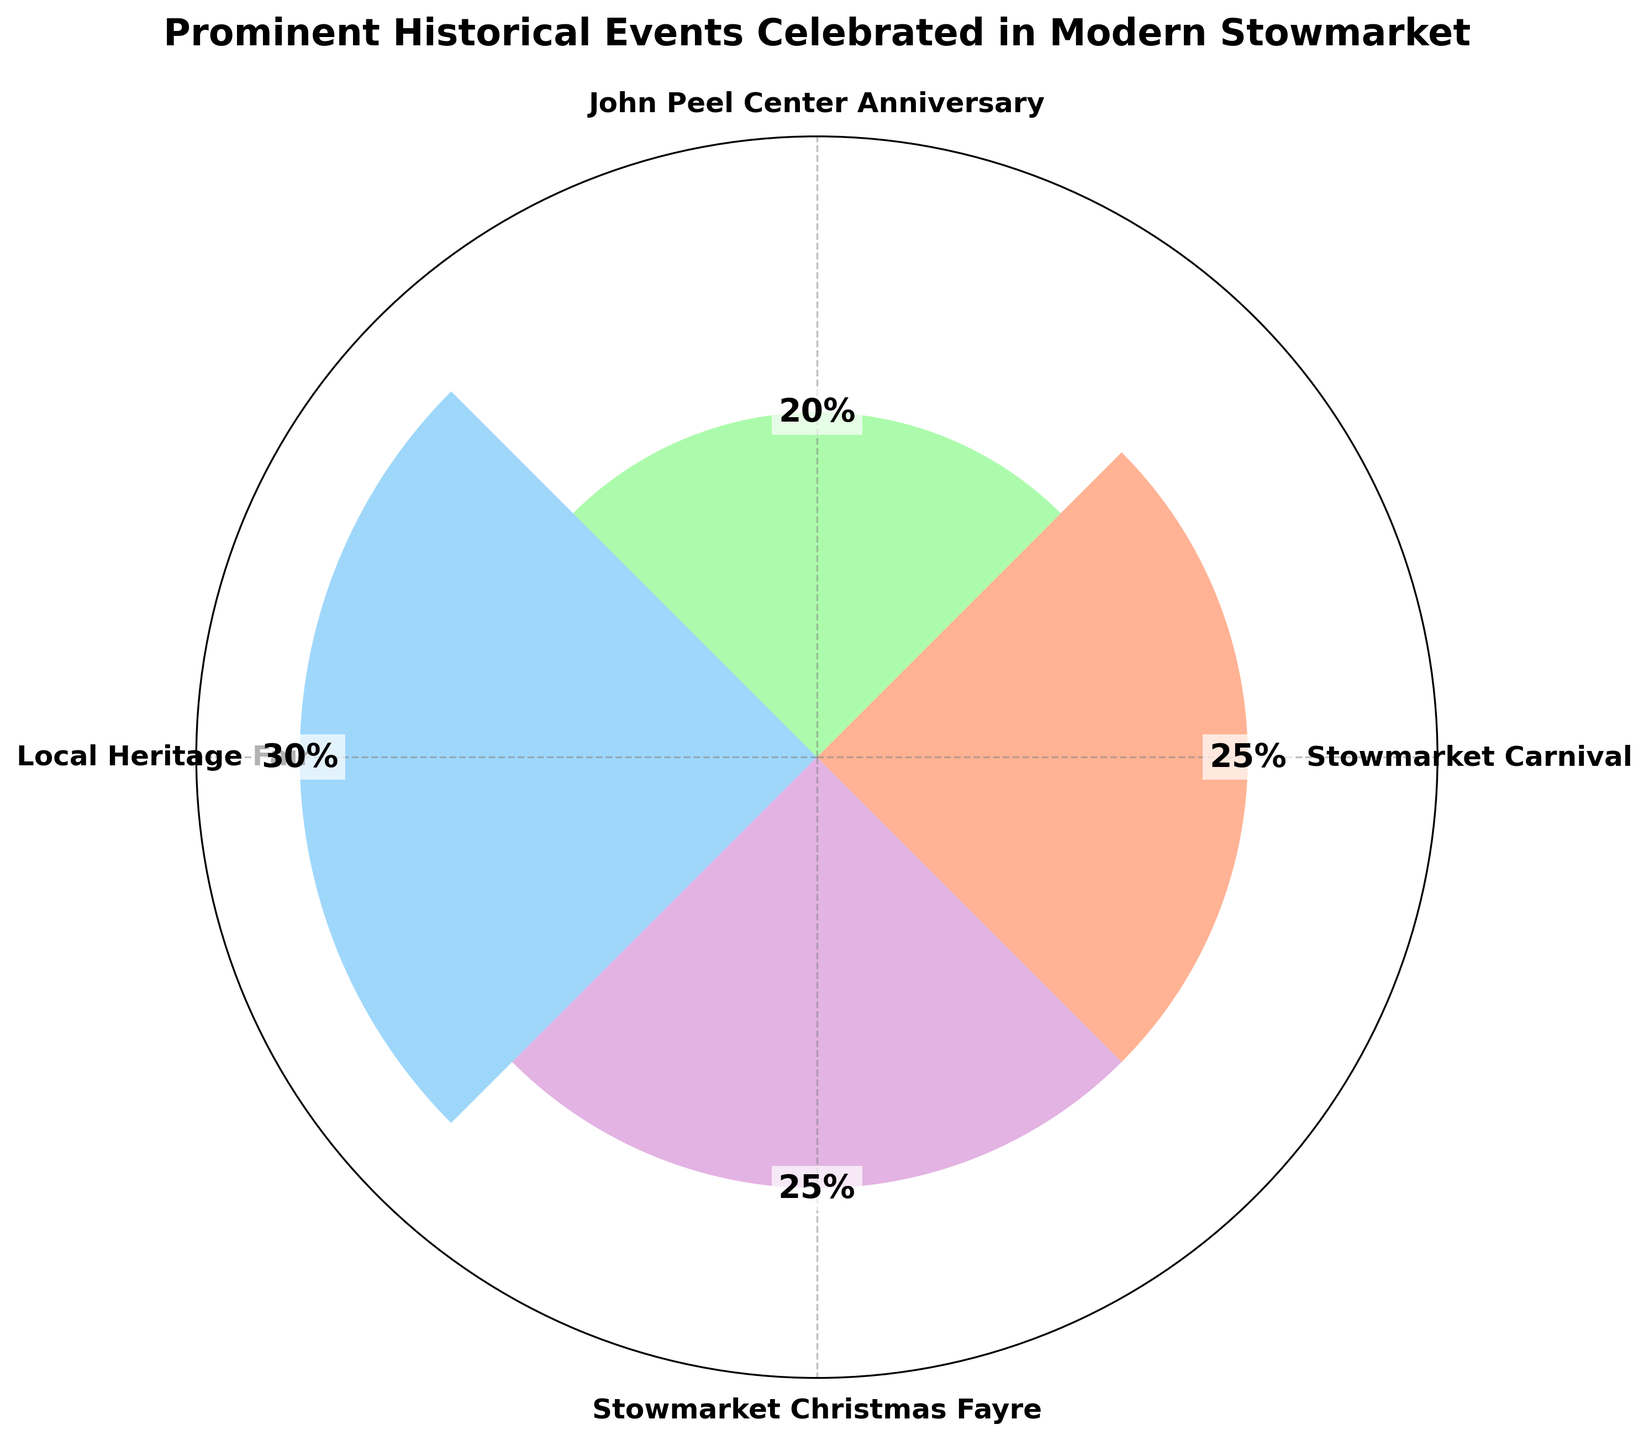What is the title of the chart? The title of the chart is displayed at the top, reading, "Prominent Historical Events Celebrated in Modern Stowmarket".
Answer: Prominent Historical Events Celebrated in Modern Stowmarket How many events are listed in the chart? By counting the distinct event names along the radial axis, there are four events.
Answer: Four Which event has the highest percentage of occurrences? The event with the highest value on the radii axis is "Local Heritage Fair" with a value of 30%.
Answer: Local Heritage Fair Which two events have the same percentage of occurrences? By comparing the values displayed next to the bars, both "Stowmarket Carnival" and "Stowmarket Christmas Fayre" have 25% occurrences each.
Answer: Stowmarket Carnival and Stowmarket Christmas Fayre What is the combined percentage of the "John Peel Center Anniversary" and "Stowmarket Christmas Fayre"? Adding the percentages of "John Peel Center Anniversary" (20%) and "Stowmarket Christmas Fayre" (25%), the combined percentage is 45%.
Answer: 45% Which event has the second-highest percentage of occurrences? The second-highest percentage after "Local Heritage Fair" (30%) is "Stowmarket Carnival" and "Stowmarket Christmas Fayre", both with 25%.
Answer: Stowmarket Carnival and Stowmarket Christmas Fayre What is the difference in the percentage of occurrences between the "Stowmarket Carnival" and the "John Peel Center Anniversary"? Subtracting the percentage of "John Peel Center Anniversary" (20%) from "Stowmarket Carnival" (25%), the difference is 5%.
Answer: 5% What is the average percentage of all the events? Adding the percentages of all events (25% + 20% + 30% + 25%) and dividing by four events gives the average percentage: (100% / 4) = 25%.
Answer: 25% Which event is displayed using a green color? The bar colored green corresponds to the "John Peel Center Anniversary".
Answer: John Peel Center Anniversary 